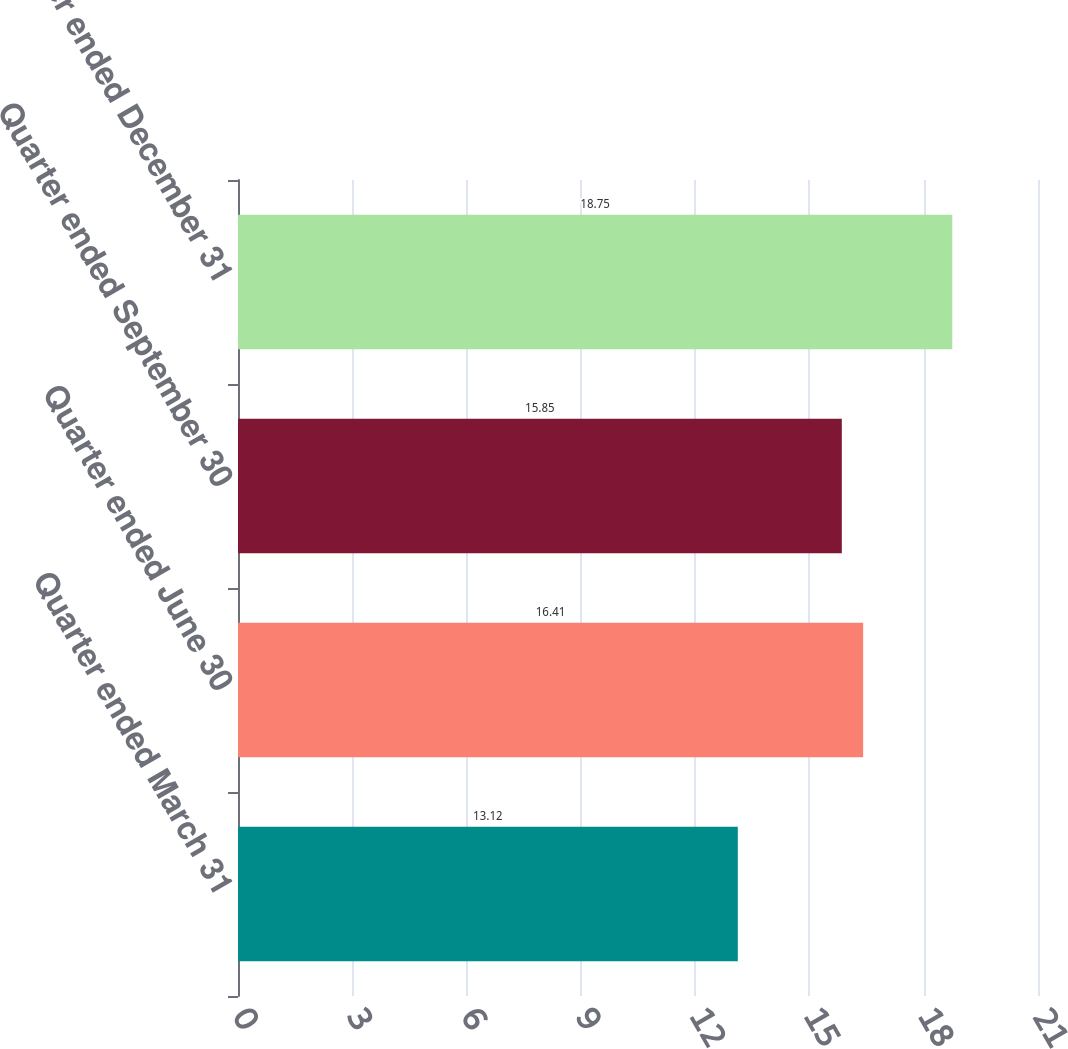<chart> <loc_0><loc_0><loc_500><loc_500><bar_chart><fcel>Quarter ended March 31<fcel>Quarter ended June 30<fcel>Quarter ended September 30<fcel>Quarter ended December 31<nl><fcel>13.12<fcel>16.41<fcel>15.85<fcel>18.75<nl></chart> 